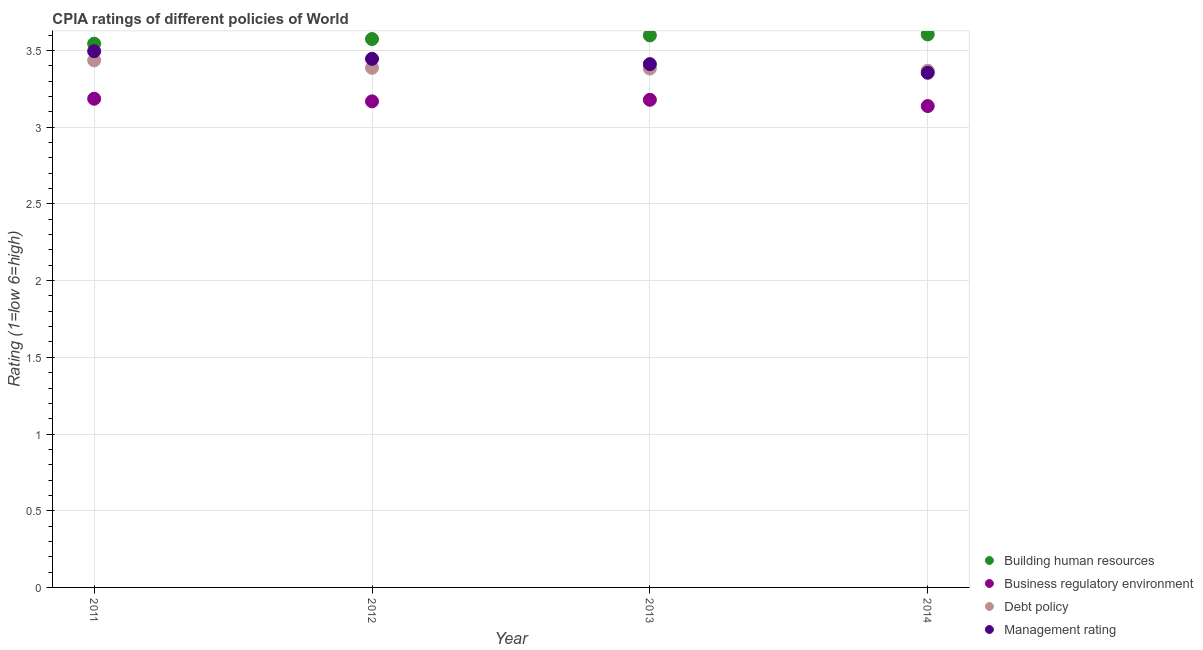What is the cpia rating of debt policy in 2014?
Make the answer very short. 3.37. Across all years, what is the maximum cpia rating of building human resources?
Your response must be concise. 3.61. Across all years, what is the minimum cpia rating of building human resources?
Offer a terse response. 3.54. What is the total cpia rating of debt policy in the graph?
Provide a succinct answer. 13.57. What is the difference between the cpia rating of business regulatory environment in 2012 and that in 2014?
Offer a terse response. 0.03. What is the difference between the cpia rating of debt policy in 2011 and the cpia rating of management in 2012?
Give a very brief answer. -0.01. What is the average cpia rating of building human resources per year?
Offer a very short reply. 3.58. What is the ratio of the cpia rating of debt policy in 2011 to that in 2012?
Provide a short and direct response. 1.01. Is the difference between the cpia rating of building human resources in 2013 and 2014 greater than the difference between the cpia rating of management in 2013 and 2014?
Your answer should be compact. No. What is the difference between the highest and the second highest cpia rating of building human resources?
Your response must be concise. 0.01. What is the difference between the highest and the lowest cpia rating of building human resources?
Ensure brevity in your answer.  0.06. In how many years, is the cpia rating of management greater than the average cpia rating of management taken over all years?
Keep it short and to the point. 2. Does the cpia rating of management monotonically increase over the years?
Offer a very short reply. No. What is the difference between two consecutive major ticks on the Y-axis?
Your response must be concise. 0.5. Are the values on the major ticks of Y-axis written in scientific E-notation?
Your answer should be compact. No. Does the graph contain grids?
Make the answer very short. Yes. Where does the legend appear in the graph?
Your answer should be very brief. Bottom right. How are the legend labels stacked?
Keep it short and to the point. Vertical. What is the title of the graph?
Ensure brevity in your answer.  CPIA ratings of different policies of World. Does "Third 20% of population" appear as one of the legend labels in the graph?
Your answer should be compact. No. What is the label or title of the X-axis?
Make the answer very short. Year. What is the label or title of the Y-axis?
Offer a terse response. Rating (1=low 6=high). What is the Rating (1=low 6=high) in Building human resources in 2011?
Make the answer very short. 3.54. What is the Rating (1=low 6=high) of Business regulatory environment in 2011?
Your answer should be very brief. 3.19. What is the Rating (1=low 6=high) of Debt policy in 2011?
Ensure brevity in your answer.  3.44. What is the Rating (1=low 6=high) in Management rating in 2011?
Ensure brevity in your answer.  3.5. What is the Rating (1=low 6=high) of Building human resources in 2012?
Your answer should be compact. 3.58. What is the Rating (1=low 6=high) in Business regulatory environment in 2012?
Your answer should be very brief. 3.17. What is the Rating (1=low 6=high) of Debt policy in 2012?
Make the answer very short. 3.39. What is the Rating (1=low 6=high) of Management rating in 2012?
Provide a succinct answer. 3.45. What is the Rating (1=low 6=high) of Building human resources in 2013?
Your answer should be very brief. 3.6. What is the Rating (1=low 6=high) of Business regulatory environment in 2013?
Give a very brief answer. 3.18. What is the Rating (1=low 6=high) in Debt policy in 2013?
Your response must be concise. 3.38. What is the Rating (1=low 6=high) of Management rating in 2013?
Make the answer very short. 3.41. What is the Rating (1=low 6=high) of Building human resources in 2014?
Your response must be concise. 3.61. What is the Rating (1=low 6=high) of Business regulatory environment in 2014?
Your response must be concise. 3.14. What is the Rating (1=low 6=high) in Debt policy in 2014?
Ensure brevity in your answer.  3.37. What is the Rating (1=low 6=high) in Management rating in 2014?
Your response must be concise. 3.36. Across all years, what is the maximum Rating (1=low 6=high) in Building human resources?
Provide a short and direct response. 3.61. Across all years, what is the maximum Rating (1=low 6=high) in Business regulatory environment?
Your answer should be compact. 3.19. Across all years, what is the maximum Rating (1=low 6=high) of Debt policy?
Keep it short and to the point. 3.44. Across all years, what is the maximum Rating (1=low 6=high) in Management rating?
Offer a terse response. 3.5. Across all years, what is the minimum Rating (1=low 6=high) of Building human resources?
Make the answer very short. 3.54. Across all years, what is the minimum Rating (1=low 6=high) of Business regulatory environment?
Your response must be concise. 3.14. Across all years, what is the minimum Rating (1=low 6=high) of Debt policy?
Provide a short and direct response. 3.37. Across all years, what is the minimum Rating (1=low 6=high) of Management rating?
Provide a short and direct response. 3.36. What is the total Rating (1=low 6=high) of Building human resources in the graph?
Ensure brevity in your answer.  14.32. What is the total Rating (1=low 6=high) of Business regulatory environment in the graph?
Keep it short and to the point. 12.67. What is the total Rating (1=low 6=high) of Debt policy in the graph?
Offer a very short reply. 13.57. What is the total Rating (1=low 6=high) of Management rating in the graph?
Your answer should be very brief. 13.71. What is the difference between the Rating (1=low 6=high) in Building human resources in 2011 and that in 2012?
Give a very brief answer. -0.03. What is the difference between the Rating (1=low 6=high) in Business regulatory environment in 2011 and that in 2012?
Provide a succinct answer. 0.02. What is the difference between the Rating (1=low 6=high) in Debt policy in 2011 and that in 2012?
Offer a terse response. 0.05. What is the difference between the Rating (1=low 6=high) of Management rating in 2011 and that in 2012?
Keep it short and to the point. 0.05. What is the difference between the Rating (1=low 6=high) in Building human resources in 2011 and that in 2013?
Keep it short and to the point. -0.05. What is the difference between the Rating (1=low 6=high) in Business regulatory environment in 2011 and that in 2013?
Provide a succinct answer. 0.01. What is the difference between the Rating (1=low 6=high) of Debt policy in 2011 and that in 2013?
Provide a succinct answer. 0.05. What is the difference between the Rating (1=low 6=high) of Management rating in 2011 and that in 2013?
Give a very brief answer. 0.08. What is the difference between the Rating (1=low 6=high) in Building human resources in 2011 and that in 2014?
Your answer should be compact. -0.06. What is the difference between the Rating (1=low 6=high) of Business regulatory environment in 2011 and that in 2014?
Make the answer very short. 0.05. What is the difference between the Rating (1=low 6=high) in Debt policy in 2011 and that in 2014?
Make the answer very short. 0.07. What is the difference between the Rating (1=low 6=high) of Management rating in 2011 and that in 2014?
Provide a short and direct response. 0.14. What is the difference between the Rating (1=low 6=high) in Building human resources in 2012 and that in 2013?
Ensure brevity in your answer.  -0.02. What is the difference between the Rating (1=low 6=high) in Business regulatory environment in 2012 and that in 2013?
Ensure brevity in your answer.  -0.01. What is the difference between the Rating (1=low 6=high) of Debt policy in 2012 and that in 2013?
Offer a very short reply. 0. What is the difference between the Rating (1=low 6=high) in Management rating in 2012 and that in 2013?
Your answer should be very brief. 0.03. What is the difference between the Rating (1=low 6=high) of Building human resources in 2012 and that in 2014?
Your response must be concise. -0.03. What is the difference between the Rating (1=low 6=high) of Business regulatory environment in 2012 and that in 2014?
Make the answer very short. 0.03. What is the difference between the Rating (1=low 6=high) in Debt policy in 2012 and that in 2014?
Provide a short and direct response. 0.02. What is the difference between the Rating (1=low 6=high) of Management rating in 2012 and that in 2014?
Your answer should be very brief. 0.09. What is the difference between the Rating (1=low 6=high) of Building human resources in 2013 and that in 2014?
Ensure brevity in your answer.  -0.01. What is the difference between the Rating (1=low 6=high) in Business regulatory environment in 2013 and that in 2014?
Provide a succinct answer. 0.04. What is the difference between the Rating (1=low 6=high) of Debt policy in 2013 and that in 2014?
Make the answer very short. 0.01. What is the difference between the Rating (1=low 6=high) in Management rating in 2013 and that in 2014?
Ensure brevity in your answer.  0.06. What is the difference between the Rating (1=low 6=high) of Building human resources in 2011 and the Rating (1=low 6=high) of Business regulatory environment in 2012?
Offer a terse response. 0.38. What is the difference between the Rating (1=low 6=high) of Building human resources in 2011 and the Rating (1=low 6=high) of Debt policy in 2012?
Provide a succinct answer. 0.16. What is the difference between the Rating (1=low 6=high) of Building human resources in 2011 and the Rating (1=low 6=high) of Management rating in 2012?
Your answer should be very brief. 0.1. What is the difference between the Rating (1=low 6=high) of Business regulatory environment in 2011 and the Rating (1=low 6=high) of Debt policy in 2012?
Make the answer very short. -0.2. What is the difference between the Rating (1=low 6=high) of Business regulatory environment in 2011 and the Rating (1=low 6=high) of Management rating in 2012?
Your answer should be very brief. -0.26. What is the difference between the Rating (1=low 6=high) of Debt policy in 2011 and the Rating (1=low 6=high) of Management rating in 2012?
Provide a short and direct response. -0.01. What is the difference between the Rating (1=low 6=high) of Building human resources in 2011 and the Rating (1=low 6=high) of Business regulatory environment in 2013?
Ensure brevity in your answer.  0.37. What is the difference between the Rating (1=low 6=high) in Building human resources in 2011 and the Rating (1=low 6=high) in Debt policy in 2013?
Give a very brief answer. 0.16. What is the difference between the Rating (1=low 6=high) in Building human resources in 2011 and the Rating (1=low 6=high) in Management rating in 2013?
Provide a short and direct response. 0.13. What is the difference between the Rating (1=low 6=high) of Business regulatory environment in 2011 and the Rating (1=low 6=high) of Debt policy in 2013?
Offer a terse response. -0.2. What is the difference between the Rating (1=low 6=high) of Business regulatory environment in 2011 and the Rating (1=low 6=high) of Management rating in 2013?
Keep it short and to the point. -0.23. What is the difference between the Rating (1=low 6=high) of Debt policy in 2011 and the Rating (1=low 6=high) of Management rating in 2013?
Your response must be concise. 0.02. What is the difference between the Rating (1=low 6=high) in Building human resources in 2011 and the Rating (1=low 6=high) in Business regulatory environment in 2014?
Keep it short and to the point. 0.41. What is the difference between the Rating (1=low 6=high) of Building human resources in 2011 and the Rating (1=low 6=high) of Debt policy in 2014?
Your response must be concise. 0.18. What is the difference between the Rating (1=low 6=high) in Building human resources in 2011 and the Rating (1=low 6=high) in Management rating in 2014?
Your answer should be compact. 0.19. What is the difference between the Rating (1=low 6=high) of Business regulatory environment in 2011 and the Rating (1=low 6=high) of Debt policy in 2014?
Your answer should be compact. -0.18. What is the difference between the Rating (1=low 6=high) in Business regulatory environment in 2011 and the Rating (1=low 6=high) in Management rating in 2014?
Ensure brevity in your answer.  -0.17. What is the difference between the Rating (1=low 6=high) in Debt policy in 2011 and the Rating (1=low 6=high) in Management rating in 2014?
Your answer should be compact. 0.08. What is the difference between the Rating (1=low 6=high) in Building human resources in 2012 and the Rating (1=low 6=high) in Business regulatory environment in 2013?
Offer a terse response. 0.4. What is the difference between the Rating (1=low 6=high) of Building human resources in 2012 and the Rating (1=low 6=high) of Debt policy in 2013?
Make the answer very short. 0.19. What is the difference between the Rating (1=low 6=high) in Building human resources in 2012 and the Rating (1=low 6=high) in Management rating in 2013?
Keep it short and to the point. 0.16. What is the difference between the Rating (1=low 6=high) in Business regulatory environment in 2012 and the Rating (1=low 6=high) in Debt policy in 2013?
Ensure brevity in your answer.  -0.21. What is the difference between the Rating (1=low 6=high) of Business regulatory environment in 2012 and the Rating (1=low 6=high) of Management rating in 2013?
Keep it short and to the point. -0.24. What is the difference between the Rating (1=low 6=high) of Debt policy in 2012 and the Rating (1=low 6=high) of Management rating in 2013?
Ensure brevity in your answer.  -0.02. What is the difference between the Rating (1=low 6=high) of Building human resources in 2012 and the Rating (1=low 6=high) of Business regulatory environment in 2014?
Make the answer very short. 0.44. What is the difference between the Rating (1=low 6=high) of Building human resources in 2012 and the Rating (1=low 6=high) of Debt policy in 2014?
Ensure brevity in your answer.  0.21. What is the difference between the Rating (1=low 6=high) of Building human resources in 2012 and the Rating (1=low 6=high) of Management rating in 2014?
Offer a terse response. 0.22. What is the difference between the Rating (1=low 6=high) of Business regulatory environment in 2012 and the Rating (1=low 6=high) of Debt policy in 2014?
Provide a succinct answer. -0.2. What is the difference between the Rating (1=low 6=high) in Business regulatory environment in 2012 and the Rating (1=low 6=high) in Management rating in 2014?
Offer a very short reply. -0.19. What is the difference between the Rating (1=low 6=high) in Debt policy in 2012 and the Rating (1=low 6=high) in Management rating in 2014?
Offer a terse response. 0.03. What is the difference between the Rating (1=low 6=high) in Building human resources in 2013 and the Rating (1=low 6=high) in Business regulatory environment in 2014?
Offer a terse response. 0.46. What is the difference between the Rating (1=low 6=high) of Building human resources in 2013 and the Rating (1=low 6=high) of Debt policy in 2014?
Offer a terse response. 0.23. What is the difference between the Rating (1=low 6=high) in Building human resources in 2013 and the Rating (1=low 6=high) in Management rating in 2014?
Your answer should be compact. 0.24. What is the difference between the Rating (1=low 6=high) of Business regulatory environment in 2013 and the Rating (1=low 6=high) of Debt policy in 2014?
Make the answer very short. -0.19. What is the difference between the Rating (1=low 6=high) in Business regulatory environment in 2013 and the Rating (1=low 6=high) in Management rating in 2014?
Provide a succinct answer. -0.18. What is the difference between the Rating (1=low 6=high) in Debt policy in 2013 and the Rating (1=low 6=high) in Management rating in 2014?
Your answer should be very brief. 0.03. What is the average Rating (1=low 6=high) of Building human resources per year?
Provide a succinct answer. 3.58. What is the average Rating (1=low 6=high) in Business regulatory environment per year?
Give a very brief answer. 3.17. What is the average Rating (1=low 6=high) of Debt policy per year?
Your response must be concise. 3.39. What is the average Rating (1=low 6=high) in Management rating per year?
Give a very brief answer. 3.43. In the year 2011, what is the difference between the Rating (1=low 6=high) of Building human resources and Rating (1=low 6=high) of Business regulatory environment?
Give a very brief answer. 0.36. In the year 2011, what is the difference between the Rating (1=low 6=high) of Building human resources and Rating (1=low 6=high) of Debt policy?
Your response must be concise. 0.11. In the year 2011, what is the difference between the Rating (1=low 6=high) in Building human resources and Rating (1=low 6=high) in Management rating?
Your answer should be compact. 0.05. In the year 2011, what is the difference between the Rating (1=low 6=high) of Business regulatory environment and Rating (1=low 6=high) of Debt policy?
Provide a short and direct response. -0.25. In the year 2011, what is the difference between the Rating (1=low 6=high) in Business regulatory environment and Rating (1=low 6=high) in Management rating?
Make the answer very short. -0.31. In the year 2011, what is the difference between the Rating (1=low 6=high) of Debt policy and Rating (1=low 6=high) of Management rating?
Give a very brief answer. -0.06. In the year 2012, what is the difference between the Rating (1=low 6=high) in Building human resources and Rating (1=low 6=high) in Business regulatory environment?
Your response must be concise. 0.41. In the year 2012, what is the difference between the Rating (1=low 6=high) of Building human resources and Rating (1=low 6=high) of Debt policy?
Your response must be concise. 0.19. In the year 2012, what is the difference between the Rating (1=low 6=high) in Building human resources and Rating (1=low 6=high) in Management rating?
Your response must be concise. 0.13. In the year 2012, what is the difference between the Rating (1=low 6=high) in Business regulatory environment and Rating (1=low 6=high) in Debt policy?
Your answer should be compact. -0.22. In the year 2012, what is the difference between the Rating (1=low 6=high) in Business regulatory environment and Rating (1=low 6=high) in Management rating?
Offer a very short reply. -0.28. In the year 2012, what is the difference between the Rating (1=low 6=high) of Debt policy and Rating (1=low 6=high) of Management rating?
Provide a short and direct response. -0.06. In the year 2013, what is the difference between the Rating (1=low 6=high) of Building human resources and Rating (1=low 6=high) of Business regulatory environment?
Your answer should be very brief. 0.42. In the year 2013, what is the difference between the Rating (1=low 6=high) of Building human resources and Rating (1=low 6=high) of Debt policy?
Provide a short and direct response. 0.22. In the year 2013, what is the difference between the Rating (1=low 6=high) in Building human resources and Rating (1=low 6=high) in Management rating?
Ensure brevity in your answer.  0.19. In the year 2013, what is the difference between the Rating (1=low 6=high) of Business regulatory environment and Rating (1=low 6=high) of Debt policy?
Offer a terse response. -0.2. In the year 2013, what is the difference between the Rating (1=low 6=high) of Business regulatory environment and Rating (1=low 6=high) of Management rating?
Ensure brevity in your answer.  -0.23. In the year 2013, what is the difference between the Rating (1=low 6=high) of Debt policy and Rating (1=low 6=high) of Management rating?
Offer a very short reply. -0.03. In the year 2014, what is the difference between the Rating (1=low 6=high) in Building human resources and Rating (1=low 6=high) in Business regulatory environment?
Offer a terse response. 0.47. In the year 2014, what is the difference between the Rating (1=low 6=high) in Building human resources and Rating (1=low 6=high) in Debt policy?
Your answer should be compact. 0.24. In the year 2014, what is the difference between the Rating (1=low 6=high) of Building human resources and Rating (1=low 6=high) of Management rating?
Provide a short and direct response. 0.25. In the year 2014, what is the difference between the Rating (1=low 6=high) of Business regulatory environment and Rating (1=low 6=high) of Debt policy?
Provide a short and direct response. -0.23. In the year 2014, what is the difference between the Rating (1=low 6=high) of Business regulatory environment and Rating (1=low 6=high) of Management rating?
Provide a succinct answer. -0.22. In the year 2014, what is the difference between the Rating (1=low 6=high) in Debt policy and Rating (1=low 6=high) in Management rating?
Keep it short and to the point. 0.01. What is the ratio of the Rating (1=low 6=high) of Business regulatory environment in 2011 to that in 2012?
Provide a short and direct response. 1.01. What is the ratio of the Rating (1=low 6=high) in Debt policy in 2011 to that in 2012?
Your answer should be very brief. 1.01. What is the ratio of the Rating (1=low 6=high) of Management rating in 2011 to that in 2012?
Provide a short and direct response. 1.01. What is the ratio of the Rating (1=low 6=high) in Building human resources in 2011 to that in 2013?
Provide a succinct answer. 0.98. What is the ratio of the Rating (1=low 6=high) in Debt policy in 2011 to that in 2013?
Your answer should be compact. 1.02. What is the ratio of the Rating (1=low 6=high) in Management rating in 2011 to that in 2013?
Keep it short and to the point. 1.02. What is the ratio of the Rating (1=low 6=high) in Building human resources in 2011 to that in 2014?
Ensure brevity in your answer.  0.98. What is the ratio of the Rating (1=low 6=high) of Business regulatory environment in 2011 to that in 2014?
Keep it short and to the point. 1.02. What is the ratio of the Rating (1=low 6=high) of Management rating in 2011 to that in 2014?
Give a very brief answer. 1.04. What is the ratio of the Rating (1=low 6=high) of Building human resources in 2012 to that in 2013?
Your response must be concise. 0.99. What is the ratio of the Rating (1=low 6=high) of Business regulatory environment in 2012 to that in 2013?
Offer a terse response. 1. What is the ratio of the Rating (1=low 6=high) in Debt policy in 2012 to that in 2013?
Offer a terse response. 1. What is the ratio of the Rating (1=low 6=high) of Business regulatory environment in 2012 to that in 2014?
Provide a short and direct response. 1.01. What is the ratio of the Rating (1=low 6=high) of Debt policy in 2012 to that in 2014?
Keep it short and to the point. 1.01. What is the ratio of the Rating (1=low 6=high) in Debt policy in 2013 to that in 2014?
Your response must be concise. 1. What is the ratio of the Rating (1=low 6=high) in Management rating in 2013 to that in 2014?
Provide a short and direct response. 1.02. What is the difference between the highest and the second highest Rating (1=low 6=high) in Building human resources?
Your response must be concise. 0.01. What is the difference between the highest and the second highest Rating (1=low 6=high) of Business regulatory environment?
Make the answer very short. 0.01. What is the difference between the highest and the second highest Rating (1=low 6=high) in Debt policy?
Ensure brevity in your answer.  0.05. What is the difference between the highest and the second highest Rating (1=low 6=high) in Management rating?
Offer a very short reply. 0.05. What is the difference between the highest and the lowest Rating (1=low 6=high) in Building human resources?
Your answer should be very brief. 0.06. What is the difference between the highest and the lowest Rating (1=low 6=high) in Business regulatory environment?
Provide a succinct answer. 0.05. What is the difference between the highest and the lowest Rating (1=low 6=high) in Debt policy?
Keep it short and to the point. 0.07. What is the difference between the highest and the lowest Rating (1=low 6=high) of Management rating?
Offer a terse response. 0.14. 